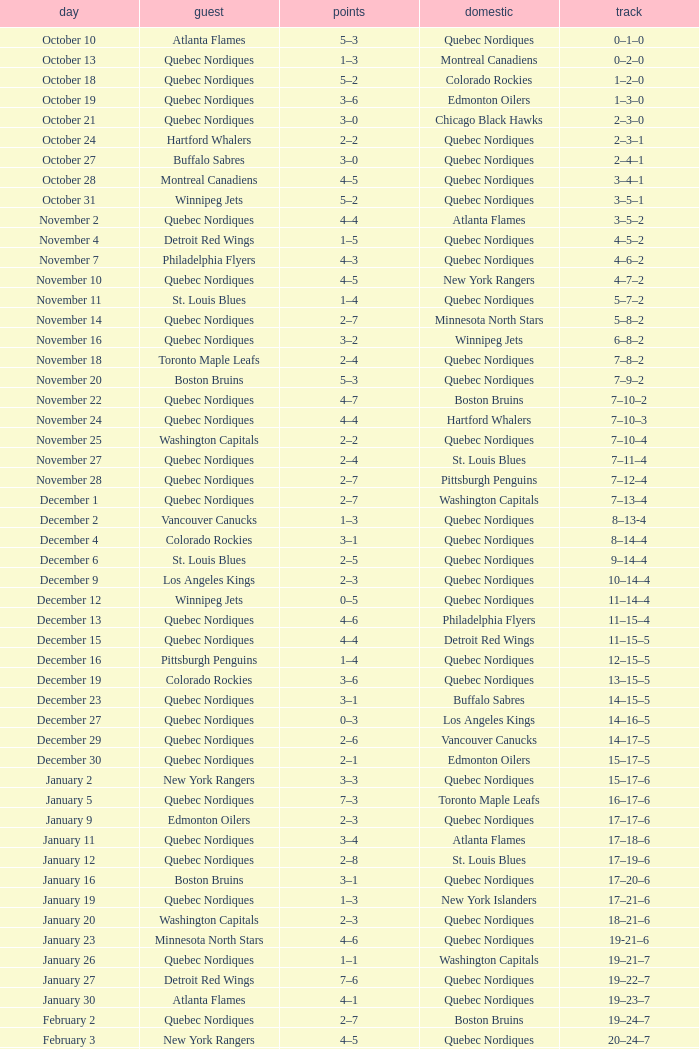Which Record has a Home of edmonton oilers, and a Score of 3–6? 1–3–0. Would you be able to parse every entry in this table? {'header': ['day', 'guest', 'points', 'domestic', 'track'], 'rows': [['October 10', 'Atlanta Flames', '5–3', 'Quebec Nordiques', '0–1–0'], ['October 13', 'Quebec Nordiques', '1–3', 'Montreal Canadiens', '0–2–0'], ['October 18', 'Quebec Nordiques', '5–2', 'Colorado Rockies', '1–2–0'], ['October 19', 'Quebec Nordiques', '3–6', 'Edmonton Oilers', '1–3–0'], ['October 21', 'Quebec Nordiques', '3–0', 'Chicago Black Hawks', '2–3–0'], ['October 24', 'Hartford Whalers', '2–2', 'Quebec Nordiques', '2–3–1'], ['October 27', 'Buffalo Sabres', '3–0', 'Quebec Nordiques', '2–4–1'], ['October 28', 'Montreal Canadiens', '4–5', 'Quebec Nordiques', '3–4–1'], ['October 31', 'Winnipeg Jets', '5–2', 'Quebec Nordiques', '3–5–1'], ['November 2', 'Quebec Nordiques', '4–4', 'Atlanta Flames', '3–5–2'], ['November 4', 'Detroit Red Wings', '1–5', 'Quebec Nordiques', '4–5–2'], ['November 7', 'Philadelphia Flyers', '4–3', 'Quebec Nordiques', '4–6–2'], ['November 10', 'Quebec Nordiques', '4–5', 'New York Rangers', '4–7–2'], ['November 11', 'St. Louis Blues', '1–4', 'Quebec Nordiques', '5–7–2'], ['November 14', 'Quebec Nordiques', '2–7', 'Minnesota North Stars', '5–8–2'], ['November 16', 'Quebec Nordiques', '3–2', 'Winnipeg Jets', '6–8–2'], ['November 18', 'Toronto Maple Leafs', '2–4', 'Quebec Nordiques', '7–8–2'], ['November 20', 'Boston Bruins', '5–3', 'Quebec Nordiques', '7–9–2'], ['November 22', 'Quebec Nordiques', '4–7', 'Boston Bruins', '7–10–2'], ['November 24', 'Quebec Nordiques', '4–4', 'Hartford Whalers', '7–10–3'], ['November 25', 'Washington Capitals', '2–2', 'Quebec Nordiques', '7–10–4'], ['November 27', 'Quebec Nordiques', '2–4', 'St. Louis Blues', '7–11–4'], ['November 28', 'Quebec Nordiques', '2–7', 'Pittsburgh Penguins', '7–12–4'], ['December 1', 'Quebec Nordiques', '2–7', 'Washington Capitals', '7–13–4'], ['December 2', 'Vancouver Canucks', '1–3', 'Quebec Nordiques', '8–13-4'], ['December 4', 'Colorado Rockies', '3–1', 'Quebec Nordiques', '8–14–4'], ['December 6', 'St. Louis Blues', '2–5', 'Quebec Nordiques', '9–14–4'], ['December 9', 'Los Angeles Kings', '2–3', 'Quebec Nordiques', '10–14–4'], ['December 12', 'Winnipeg Jets', '0–5', 'Quebec Nordiques', '11–14–4'], ['December 13', 'Quebec Nordiques', '4–6', 'Philadelphia Flyers', '11–15–4'], ['December 15', 'Quebec Nordiques', '4–4', 'Detroit Red Wings', '11–15–5'], ['December 16', 'Pittsburgh Penguins', '1–4', 'Quebec Nordiques', '12–15–5'], ['December 19', 'Colorado Rockies', '3–6', 'Quebec Nordiques', '13–15–5'], ['December 23', 'Quebec Nordiques', '3–1', 'Buffalo Sabres', '14–15–5'], ['December 27', 'Quebec Nordiques', '0–3', 'Los Angeles Kings', '14–16–5'], ['December 29', 'Quebec Nordiques', '2–6', 'Vancouver Canucks', '14–17–5'], ['December 30', 'Quebec Nordiques', '2–1', 'Edmonton Oilers', '15–17–5'], ['January 2', 'New York Rangers', '3–3', 'Quebec Nordiques', '15–17–6'], ['January 5', 'Quebec Nordiques', '7–3', 'Toronto Maple Leafs', '16–17–6'], ['January 9', 'Edmonton Oilers', '2–3', 'Quebec Nordiques', '17–17–6'], ['January 11', 'Quebec Nordiques', '3–4', 'Atlanta Flames', '17–18–6'], ['January 12', 'Quebec Nordiques', '2–8', 'St. Louis Blues', '17–19–6'], ['January 16', 'Boston Bruins', '3–1', 'Quebec Nordiques', '17–20–6'], ['January 19', 'Quebec Nordiques', '1–3', 'New York Islanders', '17–21–6'], ['January 20', 'Washington Capitals', '2–3', 'Quebec Nordiques', '18–21–6'], ['January 23', 'Minnesota North Stars', '4–6', 'Quebec Nordiques', '19-21–6'], ['January 26', 'Quebec Nordiques', '1–1', 'Washington Capitals', '19–21–7'], ['January 27', 'Detroit Red Wings', '7–6', 'Quebec Nordiques', '19–22–7'], ['January 30', 'Atlanta Flames', '4–1', 'Quebec Nordiques', '19–23–7'], ['February 2', 'Quebec Nordiques', '2–7', 'Boston Bruins', '19–24–7'], ['February 3', 'New York Rangers', '4–5', 'Quebec Nordiques', '20–24–7'], ['February 6', 'Chicago Black Hawks', '3–3', 'Quebec Nordiques', '20–24–8'], ['February 9', 'Quebec Nordiques', '0–5', 'New York Islanders', '20–25–8'], ['February 10', 'Quebec Nordiques', '1–3', 'New York Rangers', '20–26–8'], ['February 14', 'Quebec Nordiques', '1–5', 'Montreal Canadiens', '20–27–8'], ['February 17', 'Quebec Nordiques', '5–6', 'Winnipeg Jets', '20–28–8'], ['February 18', 'Quebec Nordiques', '2–6', 'Minnesota North Stars', '20–29–8'], ['February 19', 'Buffalo Sabres', '3–1', 'Quebec Nordiques', '20–30–8'], ['February 23', 'Quebec Nordiques', '1–2', 'Pittsburgh Penguins', '20–31–8'], ['February 24', 'Pittsburgh Penguins', '0–2', 'Quebec Nordiques', '21–31–8'], ['February 26', 'Hartford Whalers', '5–9', 'Quebec Nordiques', '22–31–8'], ['February 27', 'New York Islanders', '5–3', 'Quebec Nordiques', '22–32–8'], ['March 2', 'Los Angeles Kings', '4–3', 'Quebec Nordiques', '22–33–8'], ['March 5', 'Minnesota North Stars', '3-3', 'Quebec Nordiques', '22–33–9'], ['March 8', 'Quebec Nordiques', '2–3', 'Toronto Maple Leafs', '22–34–9'], ['March 9', 'Toronto Maple Leafs', '4–5', 'Quebec Nordiques', '23–34-9'], ['March 12', 'Edmonton Oilers', '6–3', 'Quebec Nordiques', '23–35–9'], ['March 16', 'Vancouver Canucks', '3–2', 'Quebec Nordiques', '23–36–9'], ['March 19', 'Quebec Nordiques', '2–5', 'Chicago Black Hawks', '23–37–9'], ['March 20', 'Quebec Nordiques', '6–2', 'Colorado Rockies', '24–37–9'], ['March 22', 'Quebec Nordiques', '1-4', 'Los Angeles Kings', '24–38-9'], ['March 23', 'Quebec Nordiques', '6–2', 'Vancouver Canucks', '25–38–9'], ['March 26', 'Chicago Black Hawks', '7–2', 'Quebec Nordiques', '25–39–9'], ['March 27', 'Quebec Nordiques', '2–5', 'Philadelphia Flyers', '25–40–9'], ['March 29', 'Quebec Nordiques', '7–9', 'Detroit Red Wings', '25–41–9'], ['March 30', 'New York Islanders', '9–6', 'Quebec Nordiques', '25–42–9'], ['April 1', 'Philadelphia Flyers', '3–3', 'Quebec Nordiques', '25–42–10'], ['April 3', 'Quebec Nordiques', '3–8', 'Buffalo Sabres', '25–43–10'], ['April 4', 'Quebec Nordiques', '2–9', 'Hartford Whalers', '25–44–10'], ['April 6', 'Montreal Canadiens', '4–4', 'Quebec Nordiques', '25–44–11']]} 